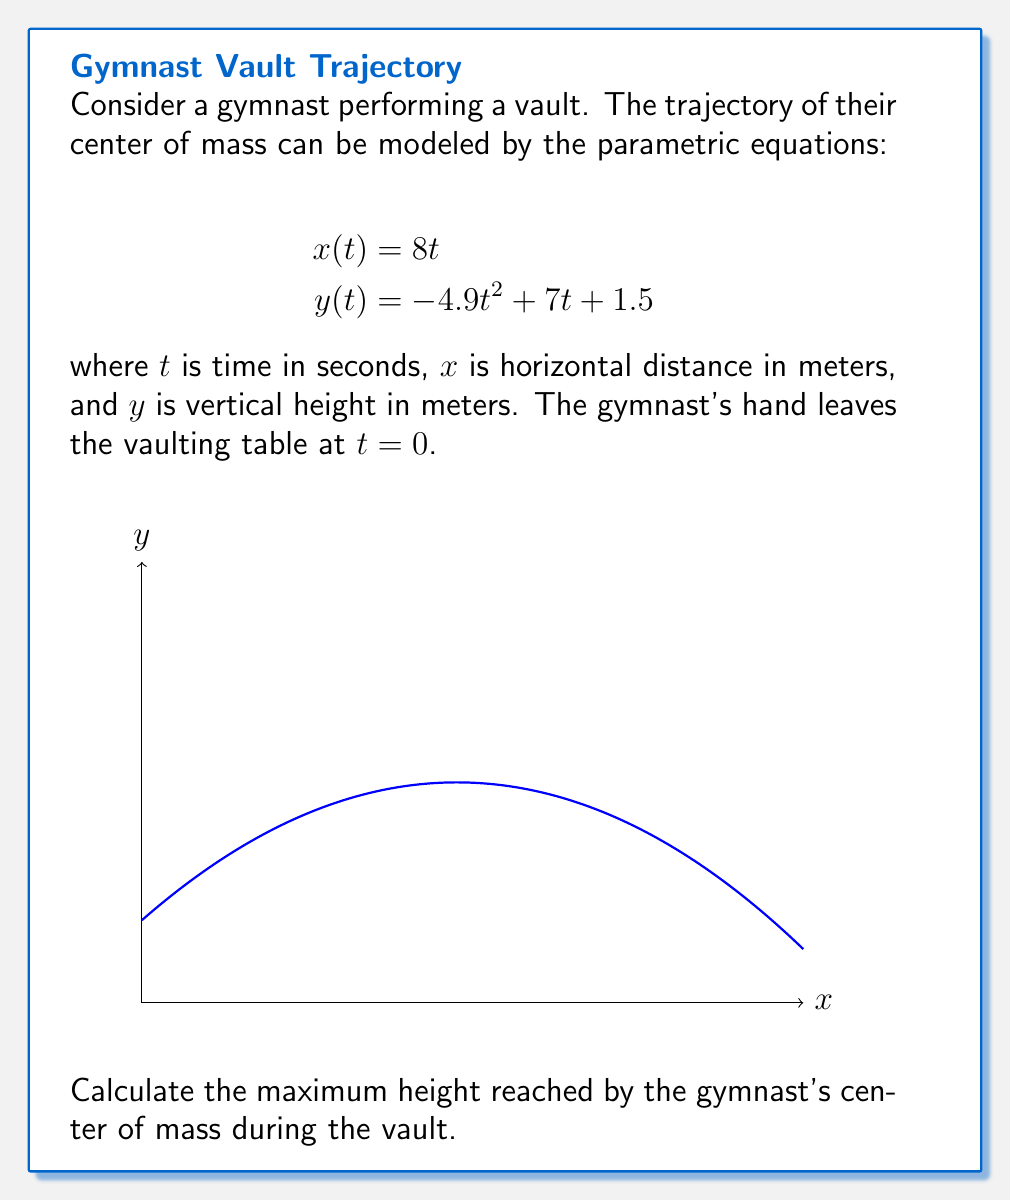What is the answer to this math problem? To find the maximum height, we need to determine when the vertical velocity is zero. Let's approach this step-by-step:

1) The vertical position is given by $y(t) = -4.9t^2 + 7t + 1.5$

2) The vertical velocity is the derivative of y with respect to t:
   $$\frac{dy}{dt} = -9.8t + 7$$

3) Set the vertical velocity to zero and solve for t:
   $$-9.8t + 7 = 0$$
   $$9.8t = 7$$
   $$t = \frac{7}{9.8} \approx 0.714 \text{ seconds}$$

4) Now, substitute this t-value back into the original equation for y:
   $$y(0.714) = -4.9(0.714)^2 + 7(0.714) + 1.5$$
   
5) Calculating this:
   $$y(0.714) = -4.9(0.510) + 5.000 + 1.5$$
   $$y(0.714) = -2.499 + 5.000 + 1.5$$
   $$y(0.714) = 4.001 \text{ meters}$$

Therefore, the maximum height reached by the gymnast's center of mass is approximately 4.001 meters.
Answer: 4.001 meters 